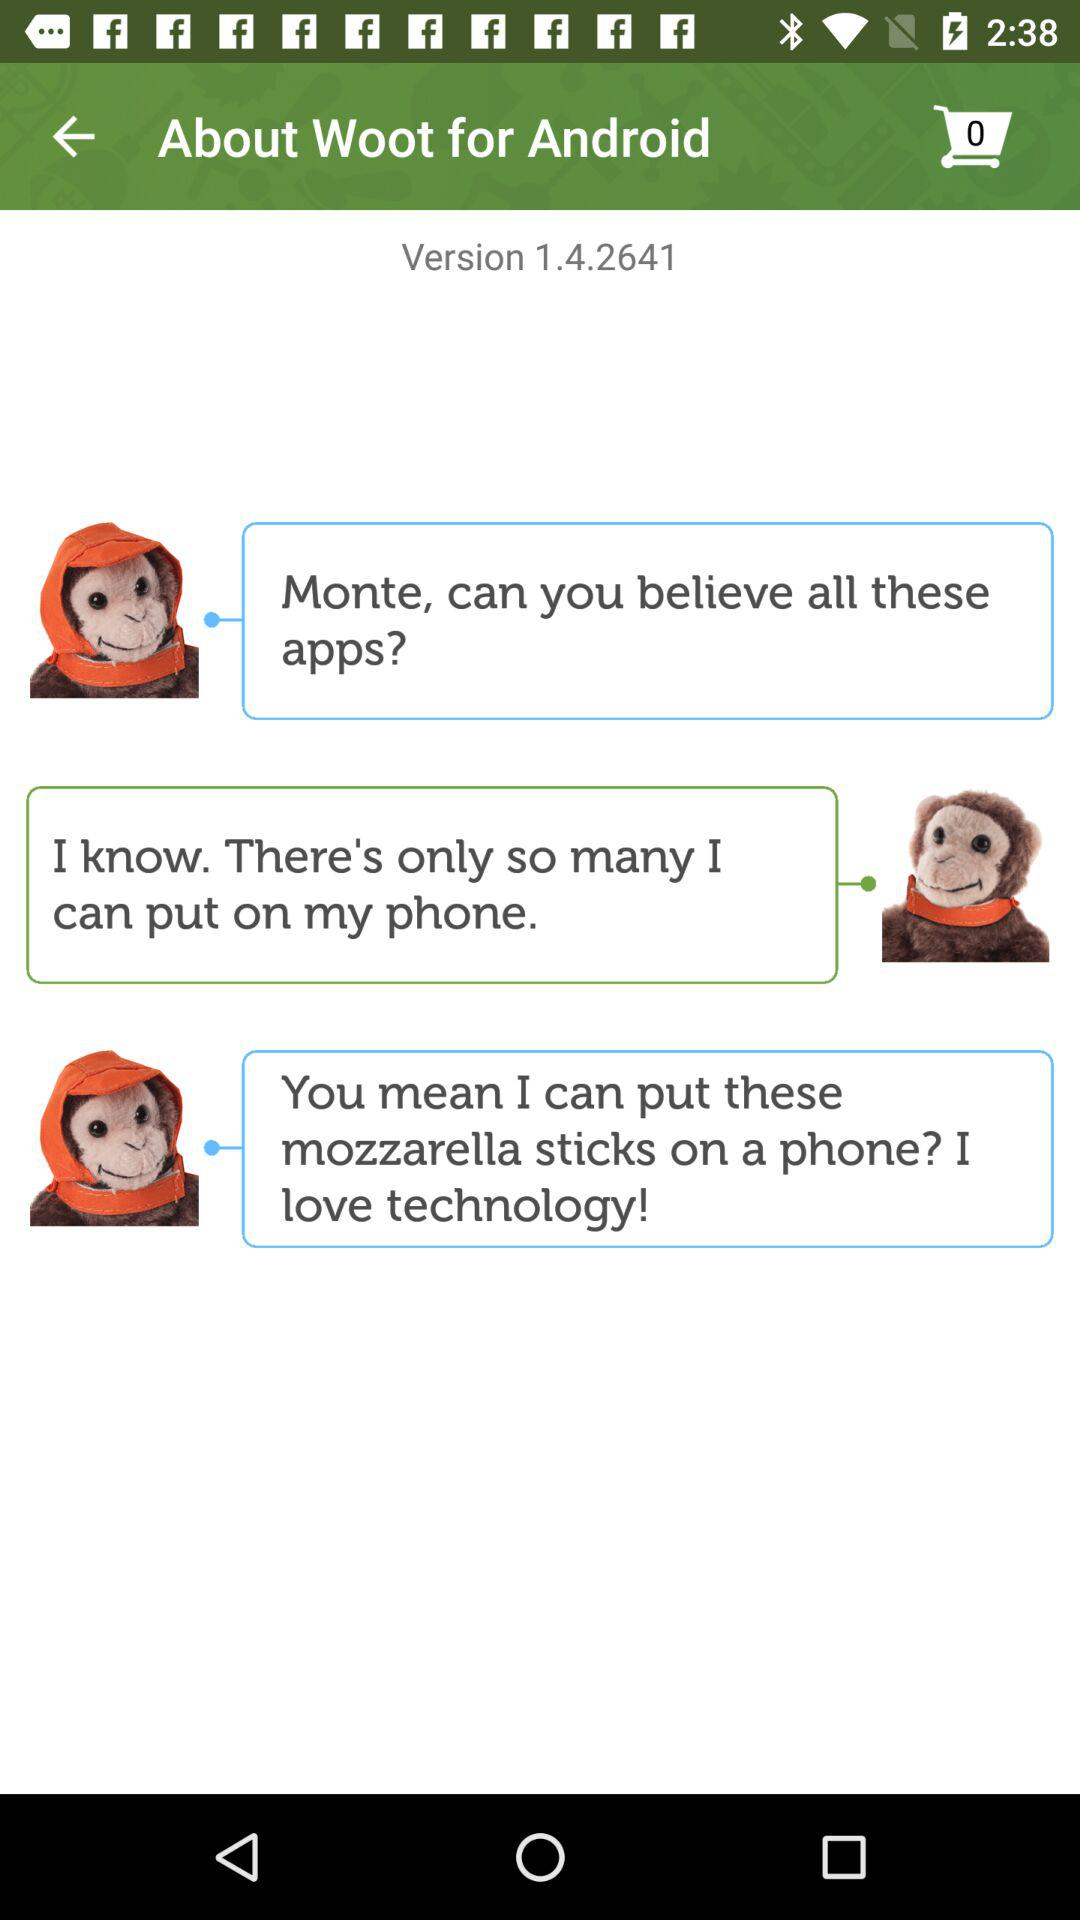What is the version of the application being used? The version is 1.4.2641. 